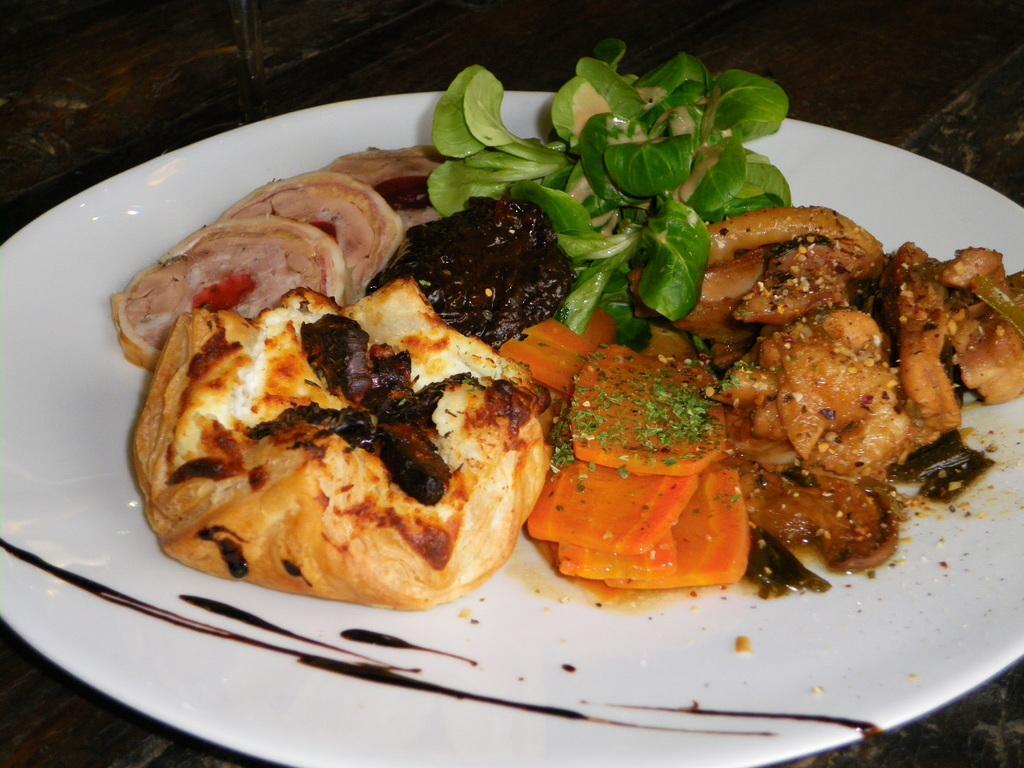Describe this image in one or two sentences. In this picture I can see food items on a white color plate. The plate is on a wooden surface. 